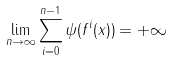Convert formula to latex. <formula><loc_0><loc_0><loc_500><loc_500>\lim _ { n \rightarrow \infty } \sum _ { i = 0 } ^ { n - 1 } \psi ( f ^ { i } ( x ) ) = + \infty</formula> 